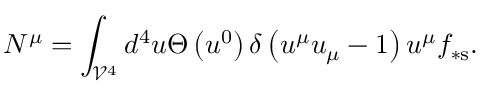<formula> <loc_0><loc_0><loc_500><loc_500>N ^ { \mu } = \int _ { \mathcal { V } ^ { 4 } } d ^ { 4 } u \Theta \left ( u ^ { 0 } \right ) \delta \left ( u ^ { \mu } u _ { \mu } - 1 \right ) u ^ { \mu } f _ { \ast s } .</formula> 